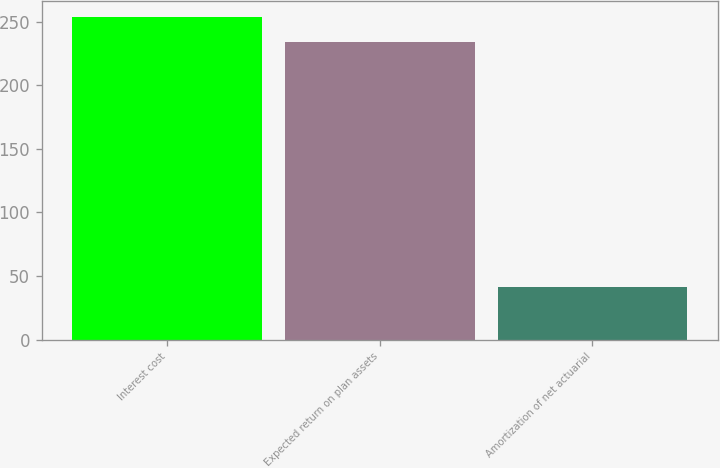Convert chart. <chart><loc_0><loc_0><loc_500><loc_500><bar_chart><fcel>Interest cost<fcel>Expected return on plan assets<fcel>Amortization of net actuarial<nl><fcel>253.5<fcel>234<fcel>41<nl></chart> 